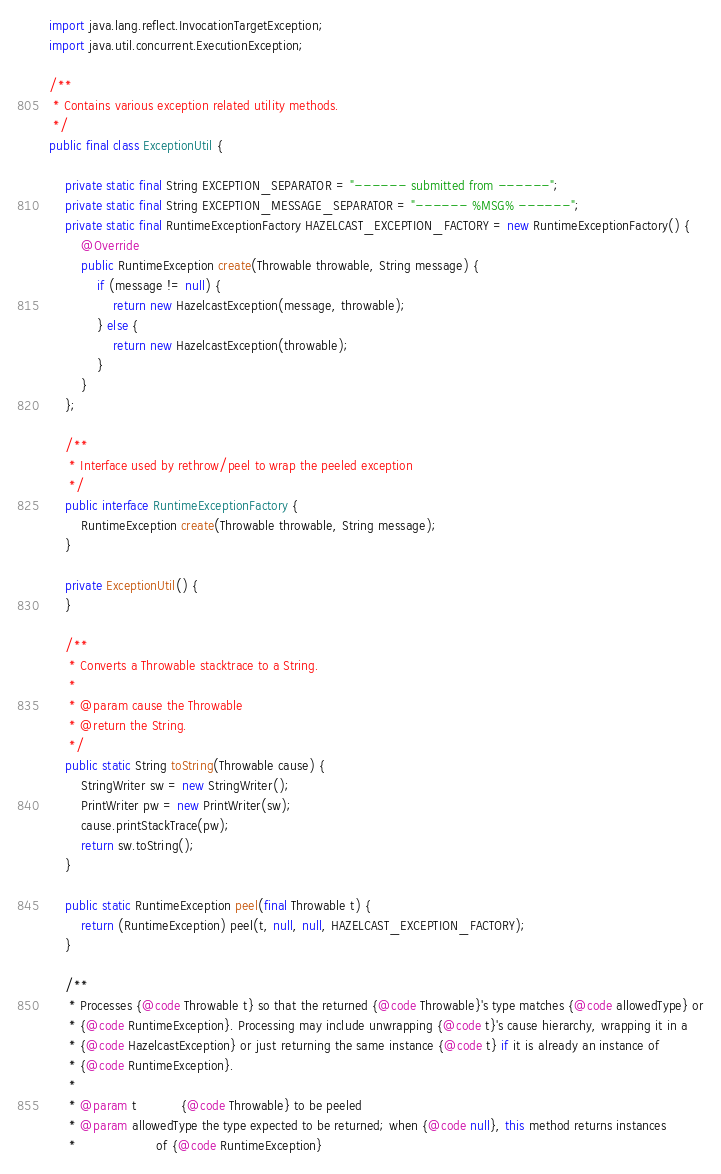<code> <loc_0><loc_0><loc_500><loc_500><_Java_>import java.lang.reflect.InvocationTargetException;
import java.util.concurrent.ExecutionException;

/**
 * Contains various exception related utility methods.
 */
public final class ExceptionUtil {

    private static final String EXCEPTION_SEPARATOR = "------ submitted from ------";
    private static final String EXCEPTION_MESSAGE_SEPARATOR = "------ %MSG% ------";
    private static final RuntimeExceptionFactory HAZELCAST_EXCEPTION_FACTORY = new RuntimeExceptionFactory() {
        @Override
        public RuntimeException create(Throwable throwable, String message) {
            if (message != null) {
                return new HazelcastException(message, throwable);
            } else {
                return new HazelcastException(throwable);
            }
        }
    };

    /**
     * Interface used by rethrow/peel to wrap the peeled exception
     */
    public interface RuntimeExceptionFactory {
        RuntimeException create(Throwable throwable, String message);
    }

    private ExceptionUtil() {
    }

    /**
     * Converts a Throwable stacktrace to a String.
     *
     * @param cause the Throwable
     * @return the String.
     */
    public static String toString(Throwable cause) {
        StringWriter sw = new StringWriter();
        PrintWriter pw = new PrintWriter(sw);
        cause.printStackTrace(pw);
        return sw.toString();
    }

    public static RuntimeException peel(final Throwable t) {
        return (RuntimeException) peel(t, null, null, HAZELCAST_EXCEPTION_FACTORY);
    }

    /**
     * Processes {@code Throwable t} so that the returned {@code Throwable}'s type matches {@code allowedType} or
     * {@code RuntimeException}. Processing may include unwrapping {@code t}'s cause hierarchy, wrapping it in a
     * {@code HazelcastException} or just returning the same instance {@code t} if it is already an instance of
     * {@code RuntimeException}.
     *
     * @param t           {@code Throwable} to be peeled
     * @param allowedType the type expected to be returned; when {@code null}, this method returns instances
     *                    of {@code RuntimeException}</code> 